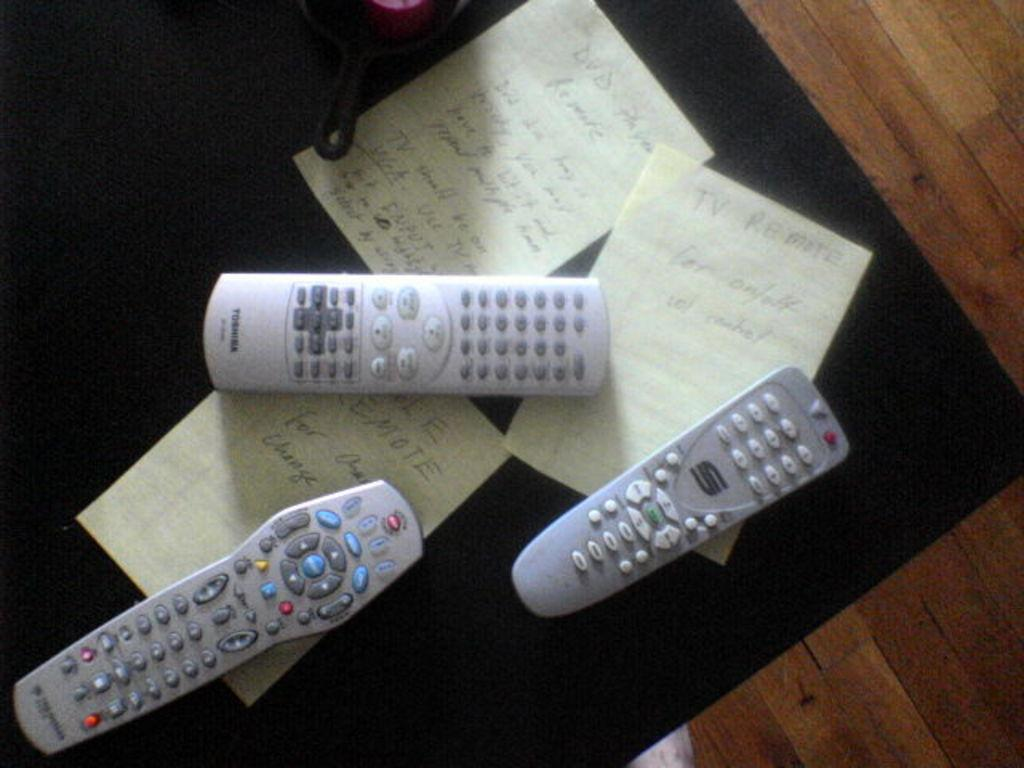<image>
Offer a succinct explanation of the picture presented. Three remote controls in silver, one of which is made by Toshiba. 